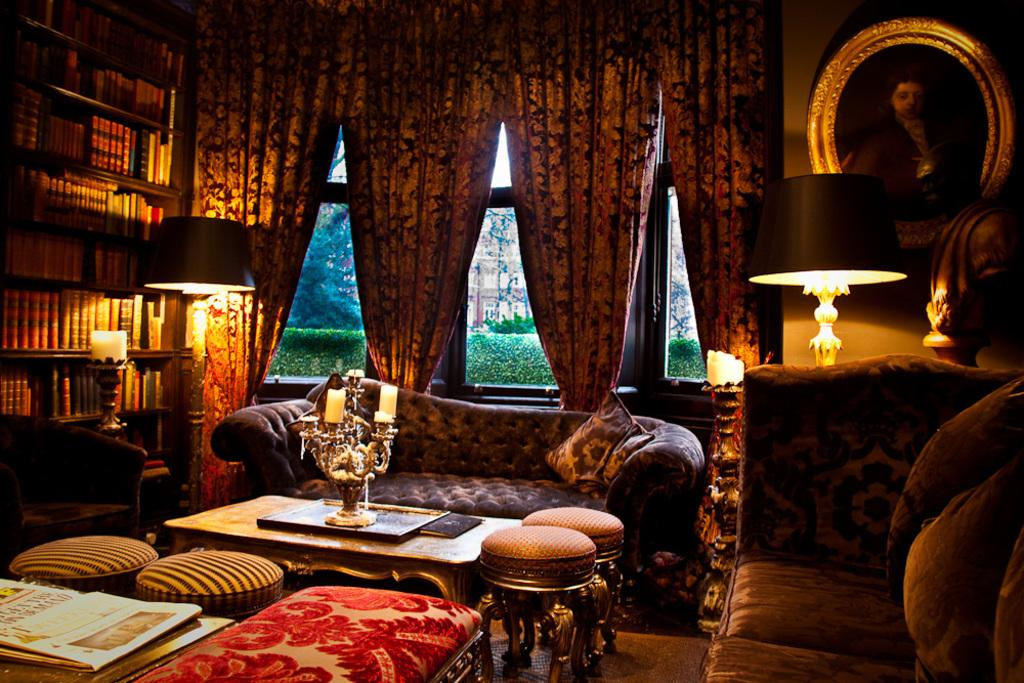How many sofas are in the image? There are two sofas in the image. What is placed on the sofas? There are cushions on the sofas. What other furniture can be seen in the image? There are stools and a table in the image. What can be seen in the background of the image? There are lamps, books, curtains, and a frame on the wall in the background of the image. What type of vein is visible on the sofas in the image? There are no veins visible on the sofas in the image. Can you see a wren perched on the frame in the background of the image? There is no wren present in the image. 